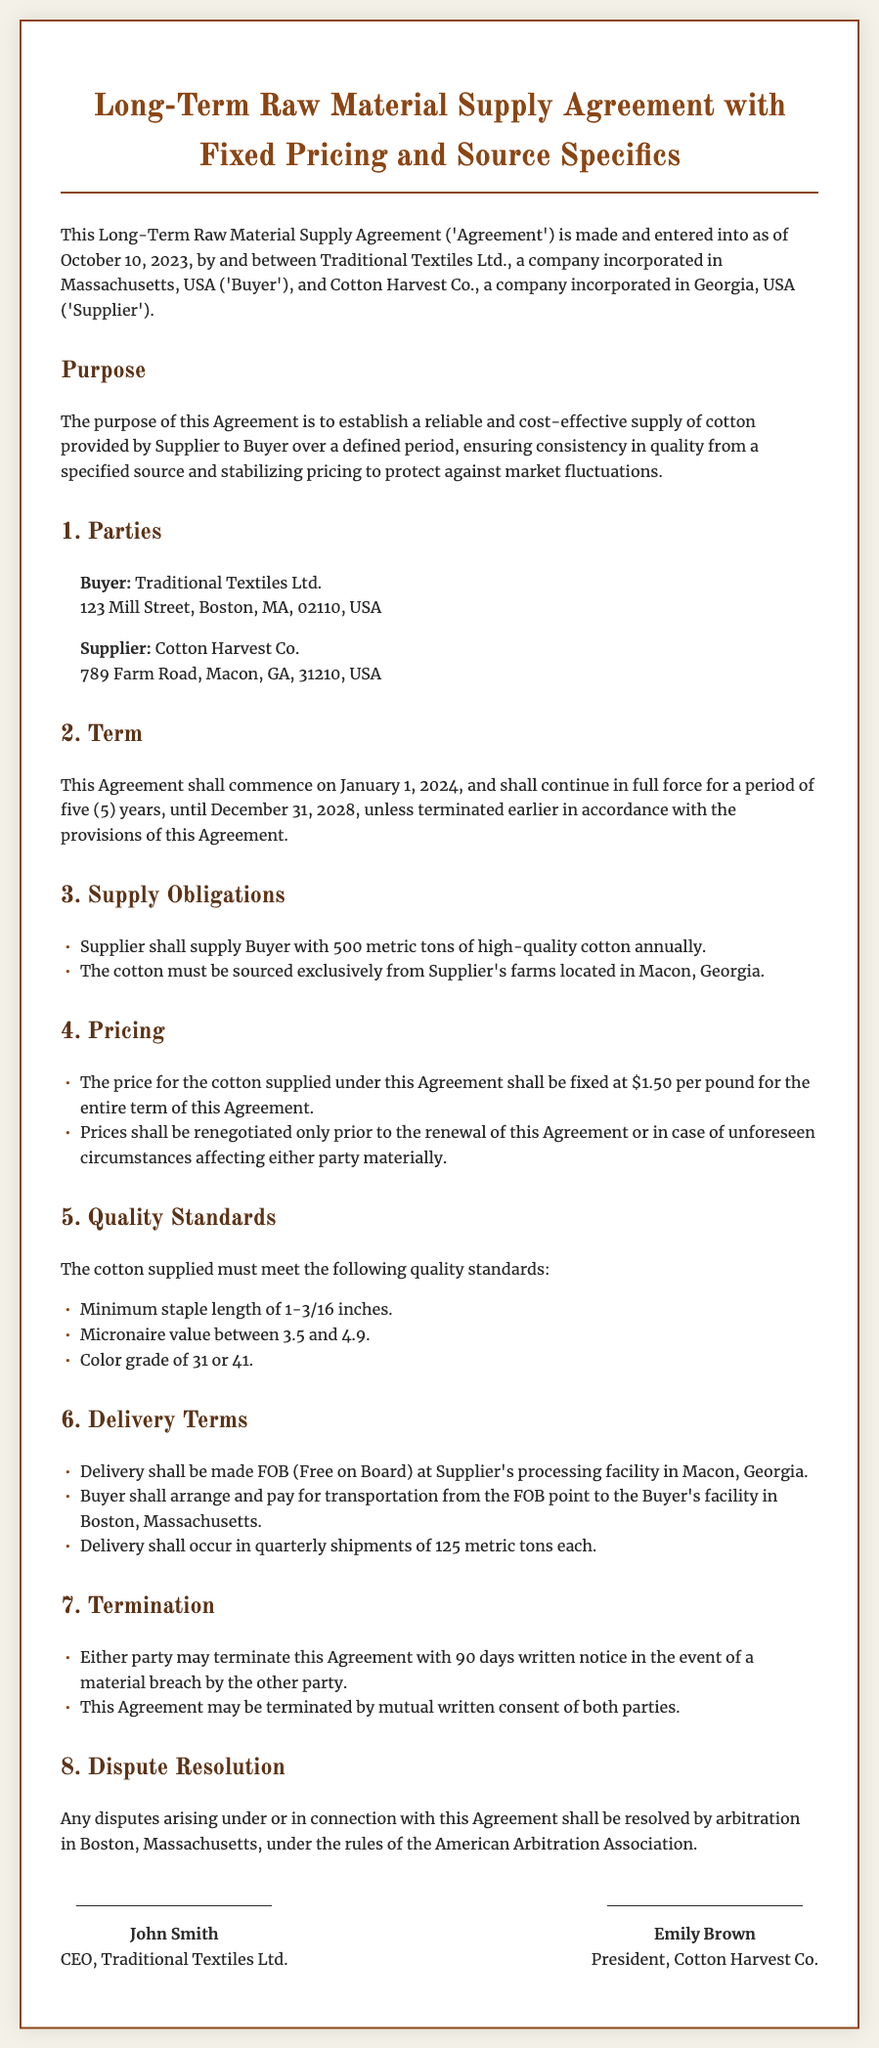What is the date of the agreement? The agreement is made as of October 10, 2023.
Answer: October 10, 2023 Who is the buyer? The buyer is Traditional Textiles Ltd.
Answer: Traditional Textiles Ltd What is the annual supply of cotton? The agreement states that the supplier shall supply 500 metric tons of cotton annually.
Answer: 500 metric tons What is the fixed price per pound of cotton? The price for the cotton supplied is fixed at $1.50 per pound.
Answer: $1.50 per pound What is the termination notice period? The notice period for termination of the agreement is 90 days.
Answer: 90 days What is the quality standard for minimum staple length? The minimum staple length requirement is 1-3/16 inches.
Answer: 1-3/16 inches Where will delivery occur? Delivery will occur at Supplier's processing facility in Macon, Georgia.
Answer: Macon, Georgia Who has to arrange transportation after delivery? The buyer must arrange and pay for transportation from the FOB point.
Answer: Buyer How long is the term of the agreement? The term of the agreement is five years.
Answer: Five years 